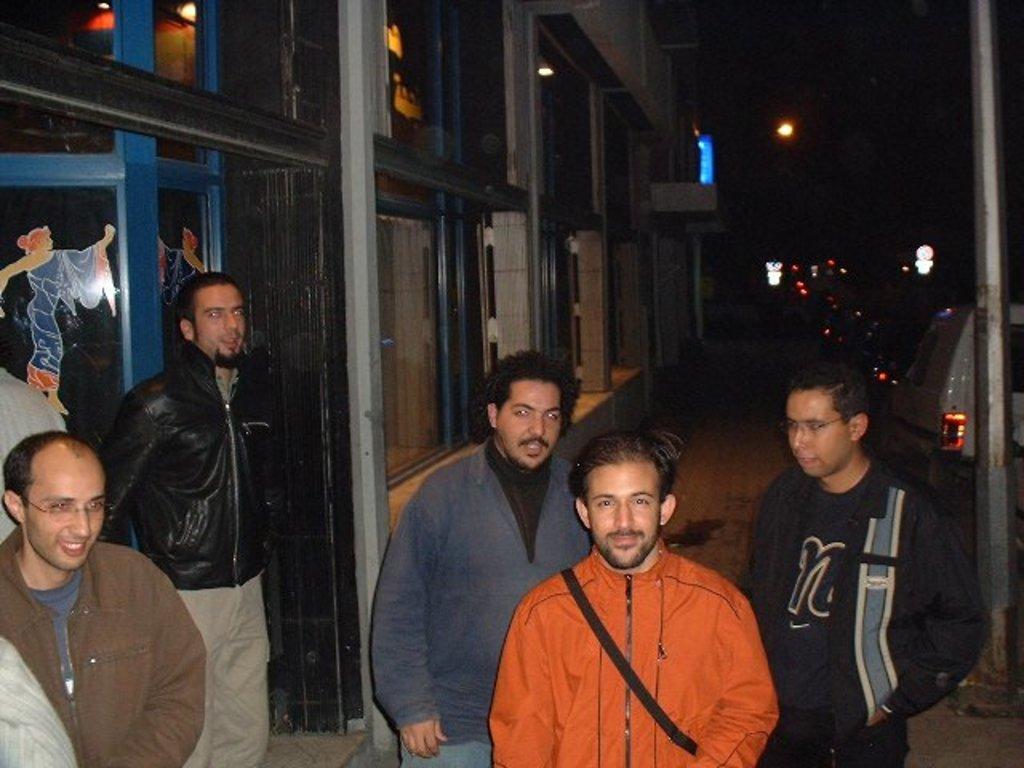Can you describe this image briefly? In this image, we can see people and are wearing coats, one of them is wearing a bag. In the background, there are vehicles on the road and we can see lights and a building. 